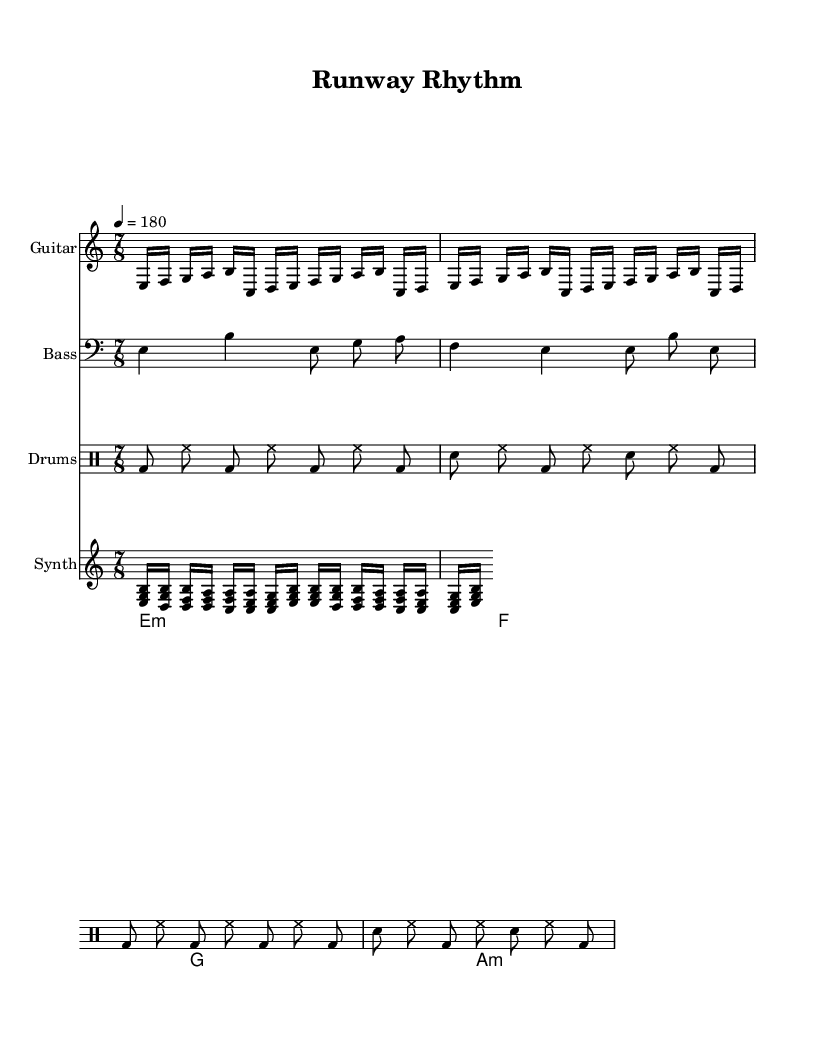What is the key signature of this music? The key signature is E Phrygian, which is indicated by the key signature marked in the header. Since it's a minor scale derived from the major scale of D, it has one flat, B, and emphasizes the note E.
Answer: E Phrygian What is the time signature of the piece? The time signature listed at the beginning is 7/8, which indicates there are seven eighth notes per measure. This is a common time signature in progressive metal that adds complexity to the rhythm.
Answer: 7/8 What is the tempo marking of the composition? The tempo marking is indicated as "4 = 180," meaning there are 180 beats per minute, with each quarter note counted as one beat. This high tempo reflects the fast-paced nature of fashion weeks, aligning with the energy of runway shows.
Answer: 180 How many measures are repeated in the guitar riff? The guitar riff has a repetition indicated by the "repeat unfold" marking, which shows that the section is played two times. This is characteristic of metal compositions to build intensity and familiarity.
Answer: 2 What type of chord progression is used in the piece? The chord progression consists of a mix of major and minor chords, specifically including E minor, F major, G major, and A minor. This variety in chords contributes to the atmospheric and dynamic quality typical in progressive metal.
Answer: E minor, F, G, A minor What is the primary rhythmic pattern for the drums? The primary rhythmic pattern for the drums alternates between bass drum (bd) and snare drum (sn), with steady hi-hat (hh) accents, maintaining a driving force typical of metal drumming and supporting the overall tempo and feel of the piece.
Answer: Bass and snare 